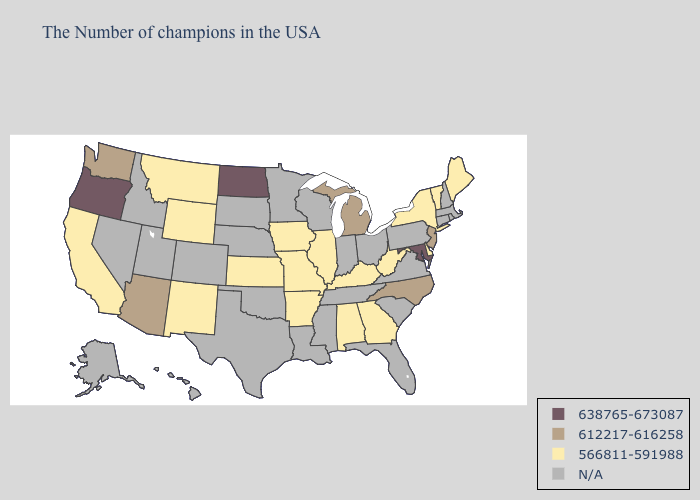What is the highest value in states that border Tennessee?
Answer briefly. 612217-616258. Name the states that have a value in the range 612217-616258?
Concise answer only. New Jersey, North Carolina, Michigan, Arizona, Washington. What is the highest value in states that border Oregon?
Answer briefly. 612217-616258. Name the states that have a value in the range N/A?
Answer briefly. Massachusetts, Rhode Island, New Hampshire, Connecticut, Pennsylvania, Virginia, South Carolina, Ohio, Florida, Indiana, Tennessee, Wisconsin, Mississippi, Louisiana, Minnesota, Nebraska, Oklahoma, Texas, South Dakota, Colorado, Utah, Idaho, Nevada, Alaska, Hawaii. Does Delaware have the lowest value in the USA?
Keep it brief. Yes. What is the value of Iowa?
Keep it brief. 566811-591988. Which states have the lowest value in the USA?
Concise answer only. Maine, Vermont, New York, Delaware, West Virginia, Georgia, Kentucky, Alabama, Illinois, Missouri, Arkansas, Iowa, Kansas, Wyoming, New Mexico, Montana, California. Name the states that have a value in the range 638765-673087?
Be succinct. Maryland, North Dakota, Oregon. What is the value of Wisconsin?
Write a very short answer. N/A. What is the highest value in states that border Nevada?
Concise answer only. 638765-673087. Which states have the lowest value in the USA?
Answer briefly. Maine, Vermont, New York, Delaware, West Virginia, Georgia, Kentucky, Alabama, Illinois, Missouri, Arkansas, Iowa, Kansas, Wyoming, New Mexico, Montana, California. Name the states that have a value in the range 612217-616258?
Give a very brief answer. New Jersey, North Carolina, Michigan, Arizona, Washington. How many symbols are there in the legend?
Answer briefly. 4. Which states have the lowest value in the West?
Short answer required. Wyoming, New Mexico, Montana, California. Name the states that have a value in the range 638765-673087?
Short answer required. Maryland, North Dakota, Oregon. 